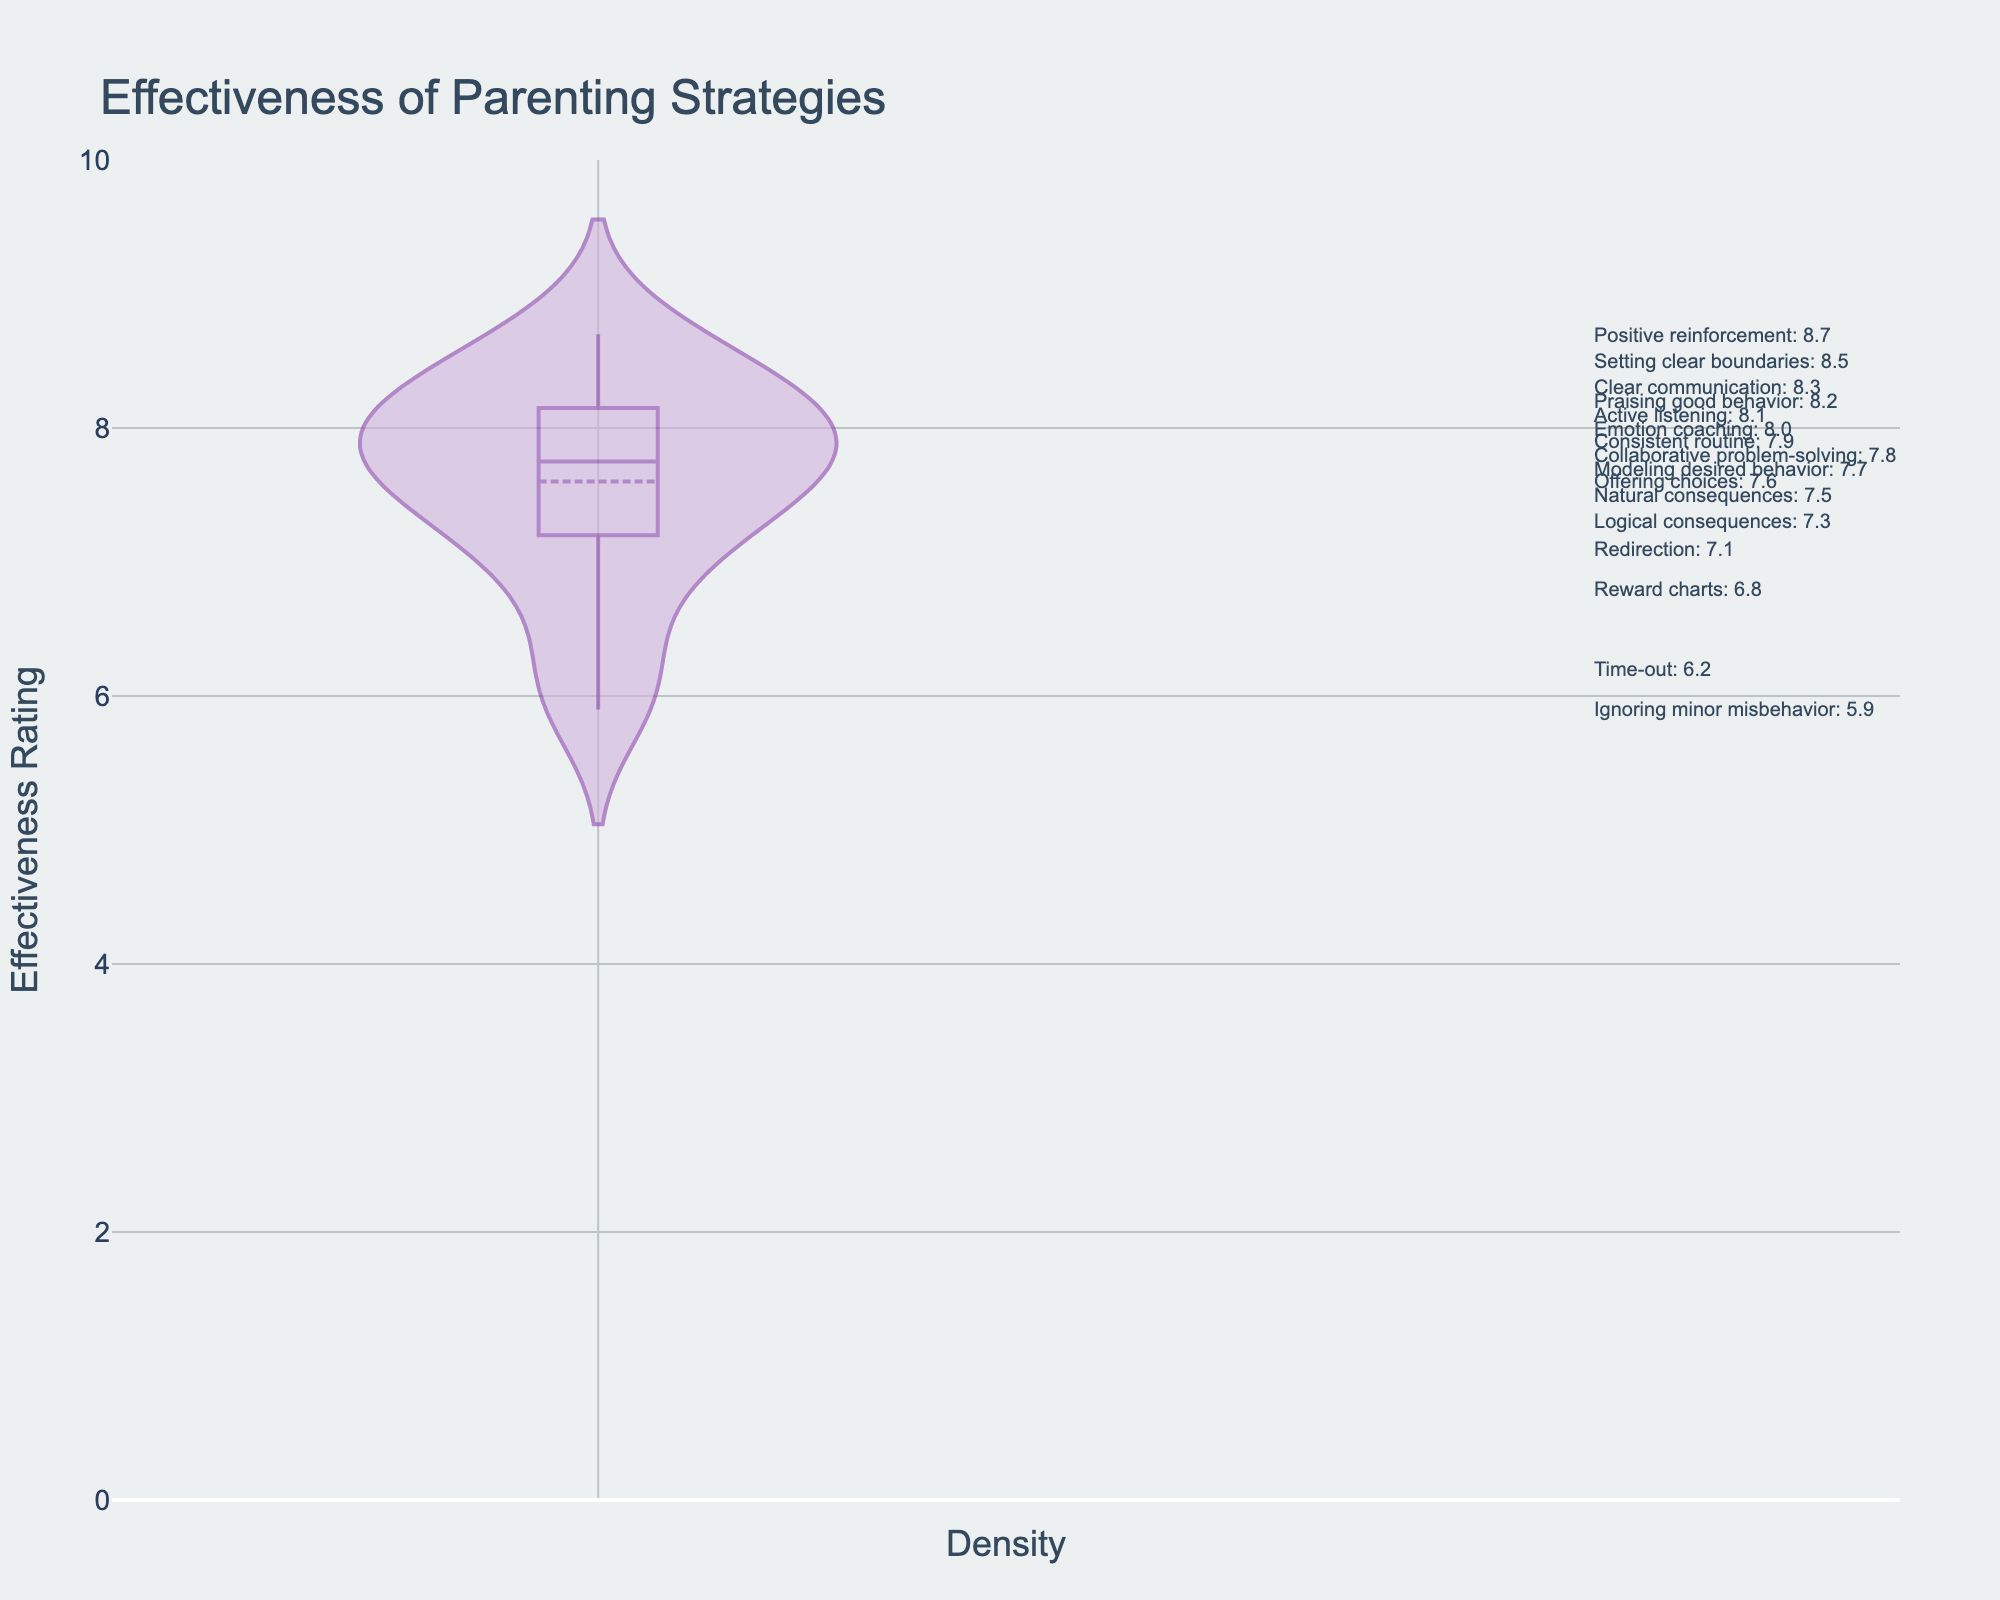How many parenting strategies are evaluated in the figure? The density plot has annotations for each parenting strategy listed, and by counting all annotations, we can determine the number of evaluated strategies.
Answer: 16 What is the effectiveness rating range depicted on the y-axis? The y-axis shows the effectiveness ratings, which ranges from the minimum to maximum values. The plot's y-axis starts at 0 and goes up to 10, as indicated by the ticks and grid lines.
Answer: 0 to 10 Which parenting strategy has the highest effectiveness rating? By looking at the annotations and the respective positions of the data points, the highest point corresponds to the highest effectiveness rating. "Positive reinforcement" has the highest rating of 8.7.
Answer: Positive reinforcement What is the difference in effectiveness ratings between Time-out and Praising good behavior? Time-out has an effectiveness rating of 6.2, and Praising good behavior has an effectiveness rating of 8.2. By subtracting the lower rating from the higher rating, we get the difference.
Answer: 2.0 How does the effectiveness rating of Ignoring minor misbehavior compare to Redirection? The density plot shows that Ignoring minor misbehavior has a rating of 5.9 and Redirection has a rating of 7.1. Comparing these two, Redirection has a higher effectiveness rating.
Answer: Redirection is higher What is the average effectiveness rating of Collaborative problem-solving, Clear communication, Setting clear boundaries, and Offering choices? The ratings are 7.8, 8.3, 8.5, and 7.6 respectively. Summing these and then dividing by the number of ratings, (7.8 + 8.3 + 8.5 + 7.6) / 4, gives the average.
Answer: 8.05 Is the effectiveness rating of Emotion coaching closer to Consistent routine or Active listening? Emotion coaching has an effectiveness rating of 8.0, while Consistent routine is 7.9 and Active listening is 8.1. Emotion coaching is equally close to both (0.1 difference each).
Answer: Equally close to both What color is used to represent the density area in the plot? The density area of the plot is represented visually with a specific color fill. Looking at the plot, the fill color for the area is a light purple or lavender.
Answer: Light purple Which strategy has a mean effectiveness rating close to 7.5? The mean line of the density plot aligns closely with the effectiveness rating annotations. "Natural consequences" has an effectiveness rating of 7.5, which aligns with the mean effectiveness rating.
Answer: Natural consequences How many strategies have an effectiveness rating of 8.0 or higher? By looking at each annotation and counting the ones with ratings 8.0 or higher, we find the strategies: Positive reinforcement (8.7), Clear communication (8.3), Setting clear boundaries (8.5), Emotion coaching (8.0), Praising good behavior (8.2), and Active listening (8.1). This makes a total of 6 strategies.
Answer: 6 